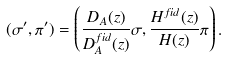Convert formula to latex. <formula><loc_0><loc_0><loc_500><loc_500>( \sigma ^ { \prime } , \pi ^ { \prime } ) = \left ( \frac { D _ { A } ( z ) } { D _ { A } ^ { f i d } ( z ) } \sigma , \frac { H ^ { f i d } ( z ) } { H ( z ) } \pi \right ) .</formula> 